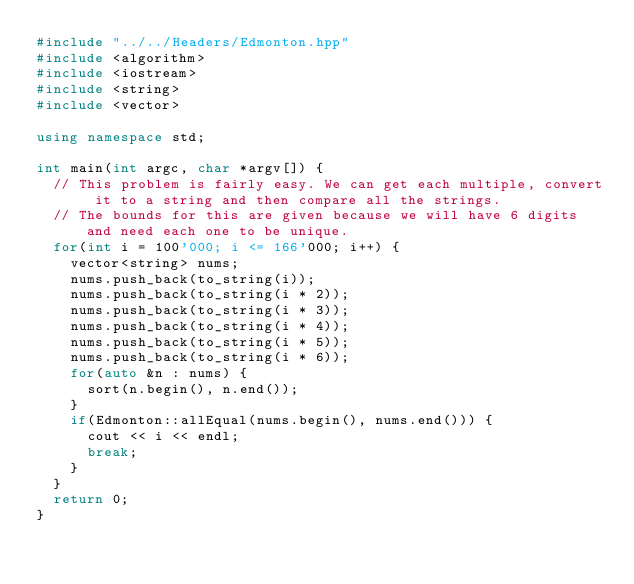Convert code to text. <code><loc_0><loc_0><loc_500><loc_500><_C++_>#include "../../Headers/Edmonton.hpp"
#include <algorithm>
#include <iostream>
#include <string>
#include <vector>

using namespace std;

int main(int argc, char *argv[]) {
	// This problem is fairly easy. We can get each multiple, convert it to a string and then compare all the strings.
	// The bounds for this are given because we will have 6 digits and need each one to be unique.
	for(int i = 100'000; i <= 166'000; i++) {
		vector<string> nums;
		nums.push_back(to_string(i));
		nums.push_back(to_string(i * 2));
		nums.push_back(to_string(i * 3));
		nums.push_back(to_string(i * 4));
		nums.push_back(to_string(i * 5));
		nums.push_back(to_string(i * 6));
		for(auto &n : nums) {
			sort(n.begin(), n.end());
		}
		if(Edmonton::allEqual(nums.begin(), nums.end())) {
			cout << i << endl;
			break;
		}
	}
	return 0;
}</code> 